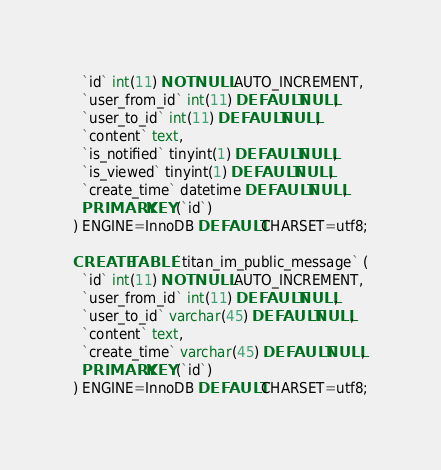Convert code to text. <code><loc_0><loc_0><loc_500><loc_500><_SQL_>  `id` int(11) NOT NULL AUTO_INCREMENT,
  `user_from_id` int(11) DEFAULT NULL,
  `user_to_id` int(11) DEFAULT NULL,
  `content` text,
  `is_notified` tinyint(1) DEFAULT NULL,
  `is_viewed` tinyint(1) DEFAULT NULL,
  `create_time` datetime DEFAULT NULL,
  PRIMARY KEY (`id`)
) ENGINE=InnoDB DEFAULT CHARSET=utf8;

CREATE TABLE `titan_im_public_message` (
  `id` int(11) NOT NULL AUTO_INCREMENT,
  `user_from_id` int(11) DEFAULT NULL,
  `user_to_id` varchar(45) DEFAULT NULL,
  `content` text,
  `create_time` varchar(45) DEFAULT NULL,
  PRIMARY KEY (`id`)
) ENGINE=InnoDB DEFAULT CHARSET=utf8;
</code> 